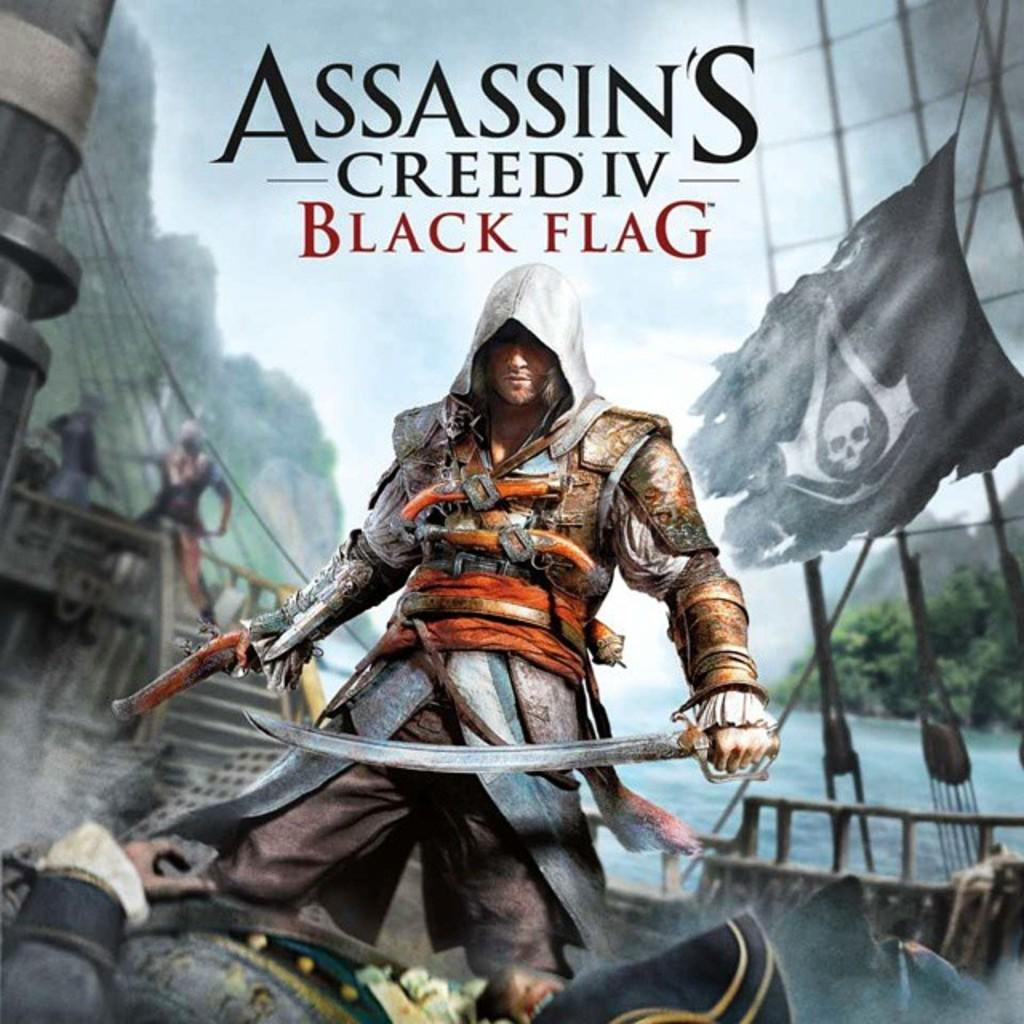<image>
Create a compact narrative representing the image presented. a game cover that is titled 'assassin's creed IV black flag' 